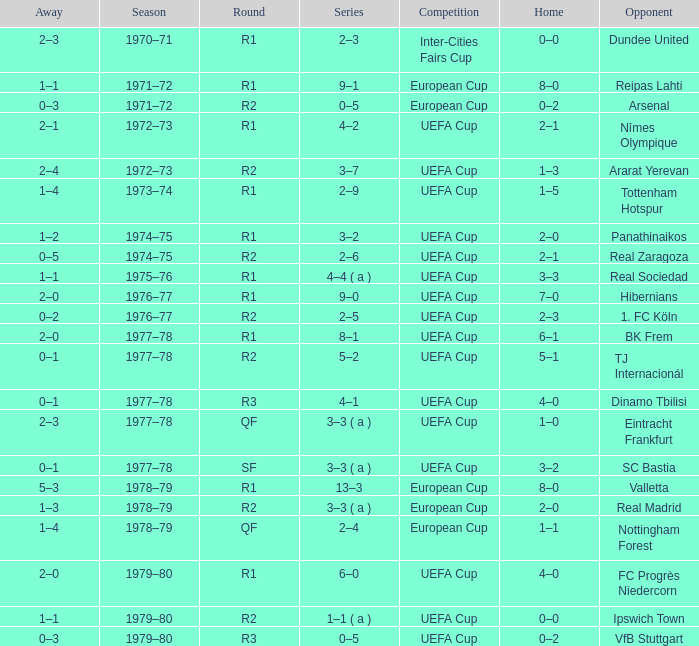Which Series has a Home of 2–0, and an Opponent of panathinaikos? 3–2. 